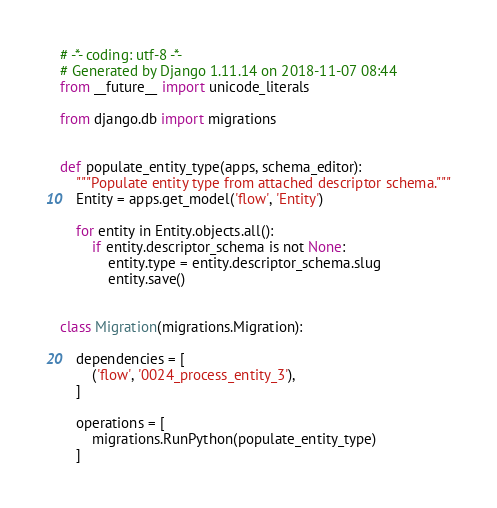<code> <loc_0><loc_0><loc_500><loc_500><_Python_># -*- coding: utf-8 -*-
# Generated by Django 1.11.14 on 2018-11-07 08:44
from __future__ import unicode_literals

from django.db import migrations


def populate_entity_type(apps, schema_editor):
    """Populate entity type from attached descriptor schema."""
    Entity = apps.get_model('flow', 'Entity')

    for entity in Entity.objects.all():
        if entity.descriptor_schema is not None:
            entity.type = entity.descriptor_schema.slug
            entity.save()


class Migration(migrations.Migration):

    dependencies = [
        ('flow', '0024_process_entity_3'),
    ]

    operations = [
        migrations.RunPython(populate_entity_type)
    ]
</code> 